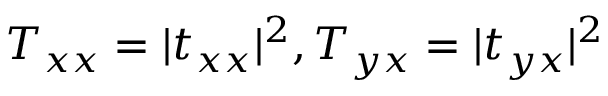Convert formula to latex. <formula><loc_0><loc_0><loc_500><loc_500>T _ { x x } = | t _ { x x } | ^ { 2 } , T _ { y x } = | t _ { y x } | ^ { 2 }</formula> 